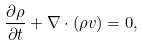Convert formula to latex. <formula><loc_0><loc_0><loc_500><loc_500>\frac { \partial \rho } { \partial t } + { \nabla } \cdot ( \rho { v } ) = 0 ,</formula> 